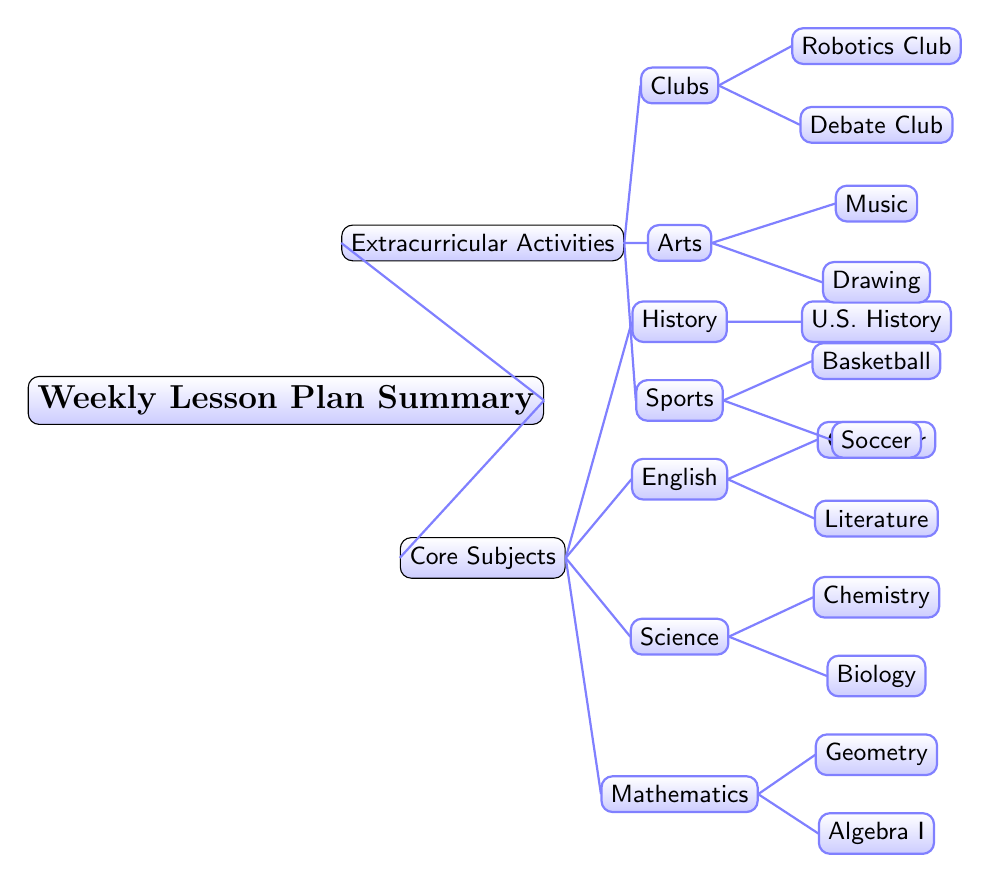What are the core subjects listed in the diagram? The core subjects are organized under the "Core Subjects" node. By examining the child nodes connected to this parent node, we can see the names of all the core subjects: Mathematics, Science, English, and History.
Answer: Mathematics, Science, English, History How many extracurricular activity categories are represented? The "Extracurricular Activities" node has three child nodes. Counting these, we find that there are three categories: Sports, Arts, and Clubs.
Answer: 3 Which subject has the subtopic of 'Grammar'? The 'Grammar' subtopic is a child node under the "English" node. By following the tree structure, we can clearly see that it falls directly under the English subject.
Answer: English What are the subtopics under the Science subject? Under the "Science" node, there are two child nodes: "Biology" and "Chemistry." These are the specific disciplines listed as subtopics of Science.
Answer: Biology, Chemistry Which extracurricular category includes 'Music'? The 'Music' activity is located under the "Arts" node, which is a child of the "Extracurricular Activities" parent node. Therefore, Music is part of the Arts extracurricular category.
Answer: Arts How many total core subjects are shown in the diagram? The total number of core subjects can be determined by counting all child nodes connected to the "Core Subjects" parent node. There are four core subjects: Mathematics, Science, English, and History.
Answer: 4 What is the one and only subtopic listed under History? The subtopic under "History" is "U.S. History." This can be seen clearly as the only child node connected to the History parent node.
Answer: U.S. History Which extracurricular activity is associated with team sports? The term "team sports" is represented by the "Basketball" and "Soccer" nodes, which are both children under the "Sports" extracurricular activities category. Therefore, Sports includes activities associated with team sports.
Answer: Sports 